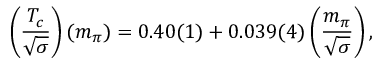<formula> <loc_0><loc_0><loc_500><loc_500>\left ( { \frac { T _ { c } } { \sqrt { \sigma } } } \right ) ( m _ { \pi } ) = 0 . 4 0 ( 1 ) + 0 . 0 3 9 ( 4 ) \left ( { \frac { m _ { \pi } } { \sqrt { \sigma } } } \right ) ,</formula> 